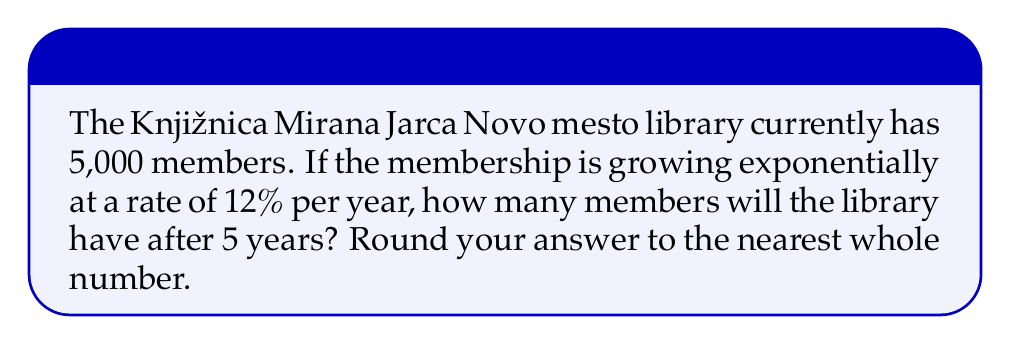Provide a solution to this math problem. To solve this problem, we'll use the exponential growth formula:

$$A = P(1 + r)^t$$

Where:
$A$ = Final amount
$P$ = Initial amount (principal)
$r$ = Growth rate (as a decimal)
$t$ = Time period

Given:
$P = 5,000$ (initial members)
$r = 0.12$ (12% growth rate)
$t = 5$ years

Let's plug these values into the formula:

$$A = 5,000(1 + 0.12)^5$$

Now, let's calculate step-by-step:

1) First, calculate $(1 + 0.12)^5$:
   $$(1.12)^5 = 1.762341968$$

2) Multiply this by the initial amount:
   $$5,000 \times 1.762341968 = 8,811.70984$$

3) Round to the nearest whole number:
   $$8,812$$

Therefore, after 5 years, the library will have approximately 8,812 members.
Answer: 8,812 members 